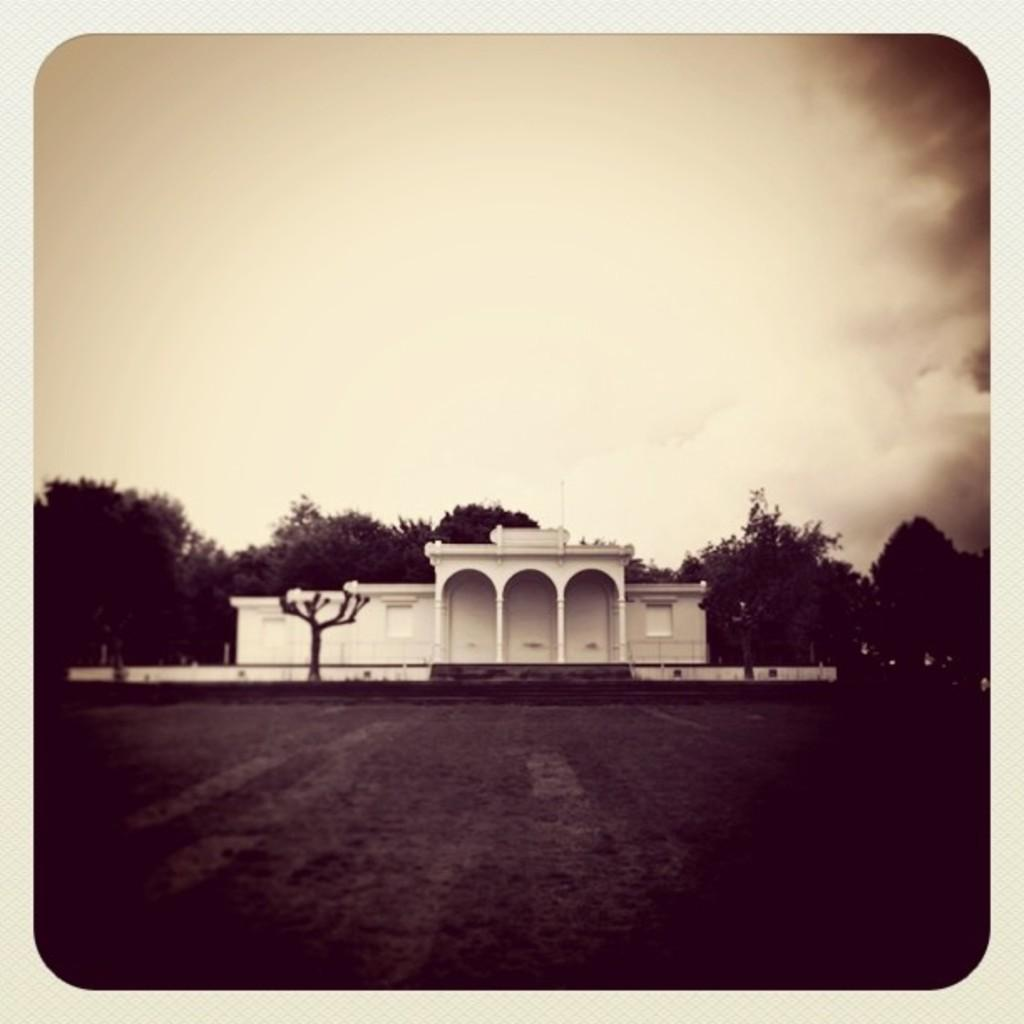What type of surface can be seen in the image? There is ground visible in the image. What type of structure is present in the image? There is a building in the image. What architectural feature can be seen in the image? There are pillars in the image. What can be seen in the background of the image? There are trees and the sky visible in the background of the image. What type of quill is being used to write on the building in the image? There is no quill or writing activity present in the image. What theory is being tested in the image? There is no experiment or theory being tested in the image. 